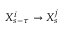<formula> <loc_0><loc_0><loc_500><loc_500>X _ { s - \tau } ^ { i } \rightarrow X _ { s } ^ { j }</formula> 